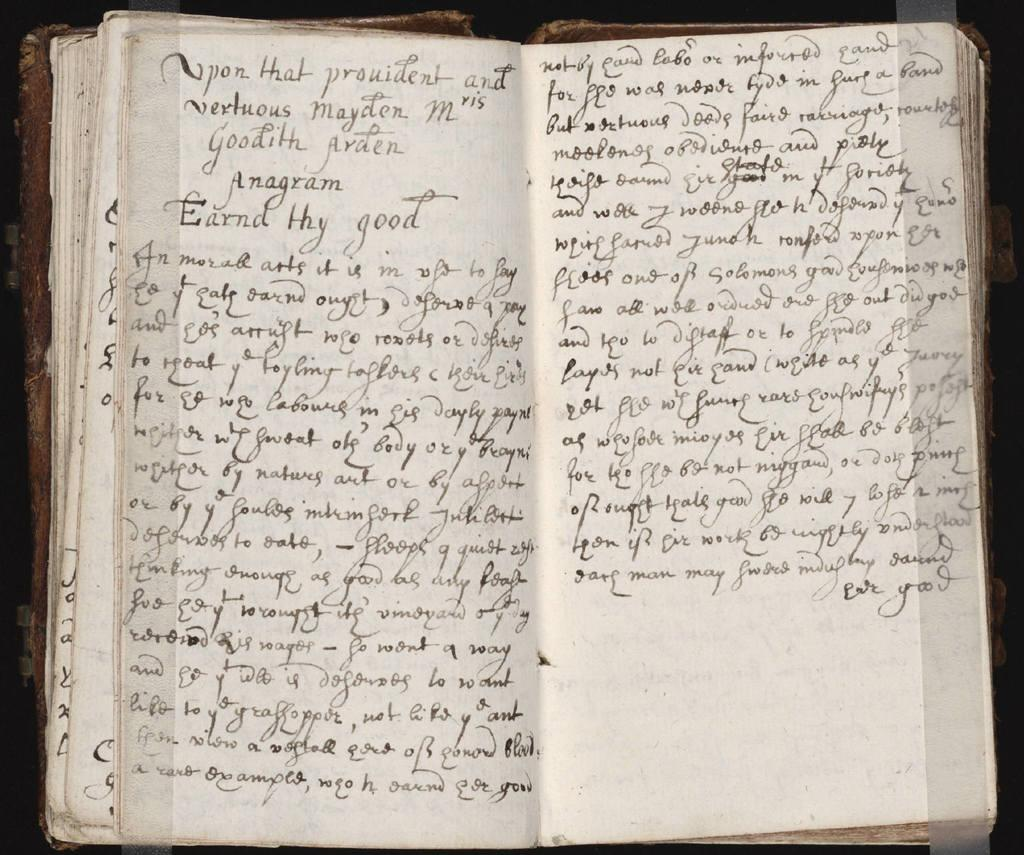<image>
Write a terse but informative summary of the picture. An old book with Earnd Thy Good written on a page. 